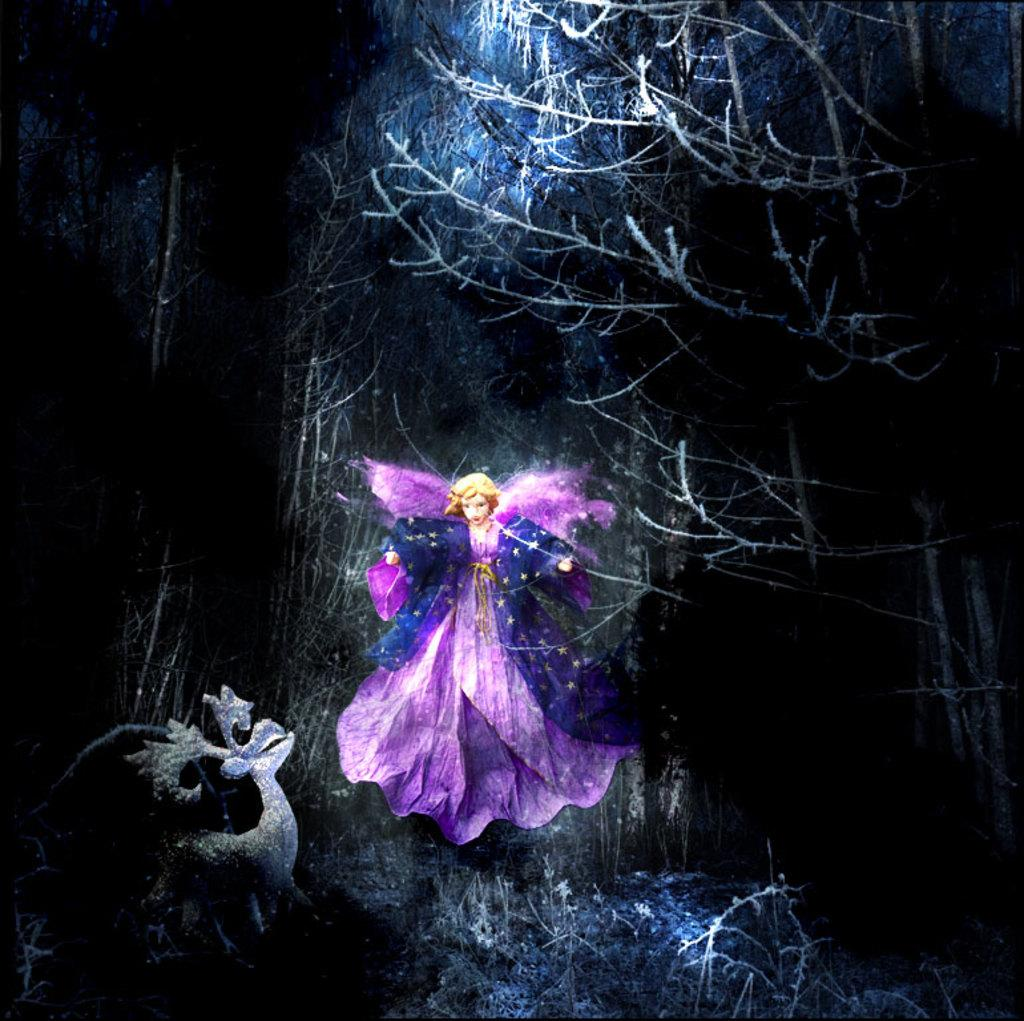What is the main subject of the image? There is an animation of a person in the center of the image. What can be seen in the background of the image? There are trees in the background of the image. What is located on the left side of the image? There is an unspecified object on the left side of the image. What type of map can be seen on the right side of the image? There is no map present in the image; it features an animation of a person, trees in the background, and an unspecified object on the left side. What kind of grain is being harvested in the image? There is no indication of any agricultural activity or grain in the image. 